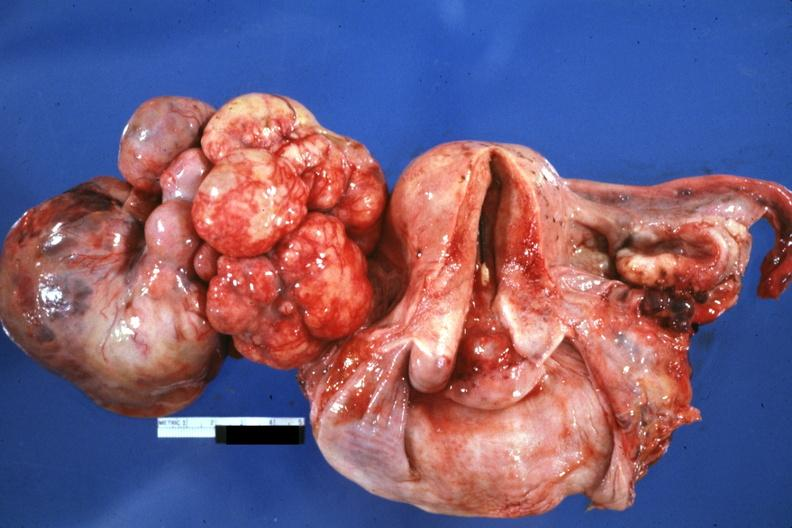s uterus present?
Answer the question using a single word or phrase. No 